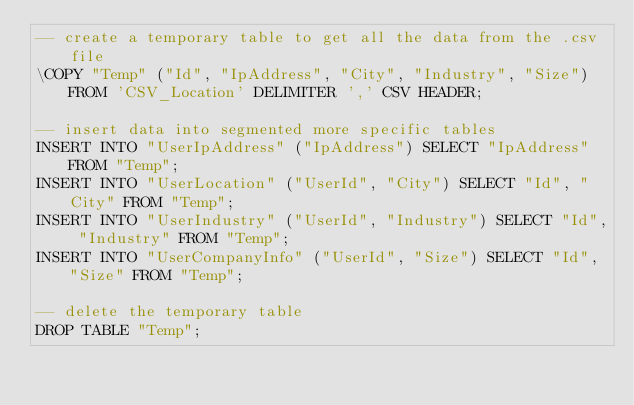<code> <loc_0><loc_0><loc_500><loc_500><_SQL_>-- create a temporary table to get all the data from the .csv file
\COPY "Temp" ("Id", "IpAddress", "City", "Industry", "Size") FROM 'CSV_Location' DELIMITER ',' CSV HEADER;

-- insert data into segmented more specific tables
INSERT INTO "UserIpAddress" ("IpAddress") SELECT "IpAddress" FROM "Temp";
INSERT INTO "UserLocation" ("UserId", "City") SELECT "Id", "City" FROM "Temp";
INSERT INTO "UserIndustry" ("UserId", "Industry") SELECT "Id", "Industry" FROM "Temp";
INSERT INTO "UserCompanyInfo" ("UserId", "Size") SELECT "Id", "Size" FROM "Temp";

-- delete the temporary table
DROP TABLE "Temp";
</code> 